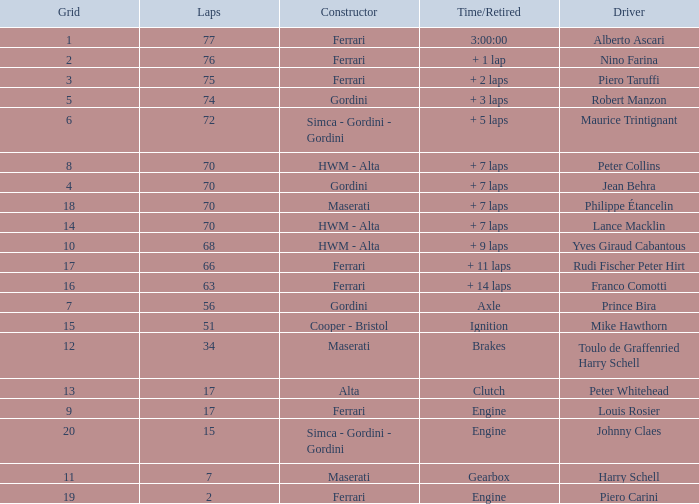What is the high grid for ferrari's with 2 laps? 19.0. 